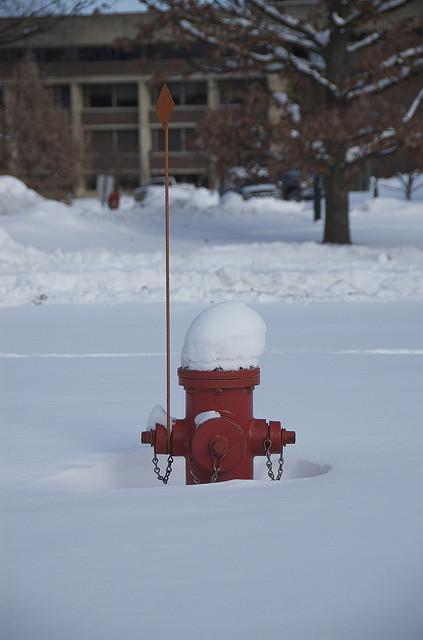Has it been snowing?
Give a very brief answer. Yes. Is it winter?
Give a very brief answer. Yes. Is there a truck in the background?
Quick response, please. No. How many chains on the hydrant?
Short answer required. 2. What color is the fire hydrant?
Write a very short answer. Red. 